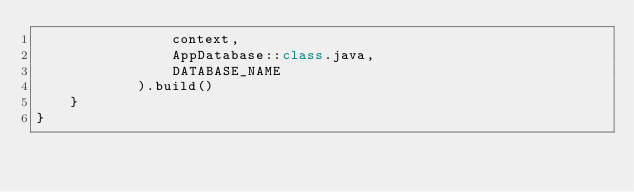<code> <loc_0><loc_0><loc_500><loc_500><_Kotlin_>                context,
                AppDatabase::class.java,
                DATABASE_NAME
            ).build()
    }
}</code> 